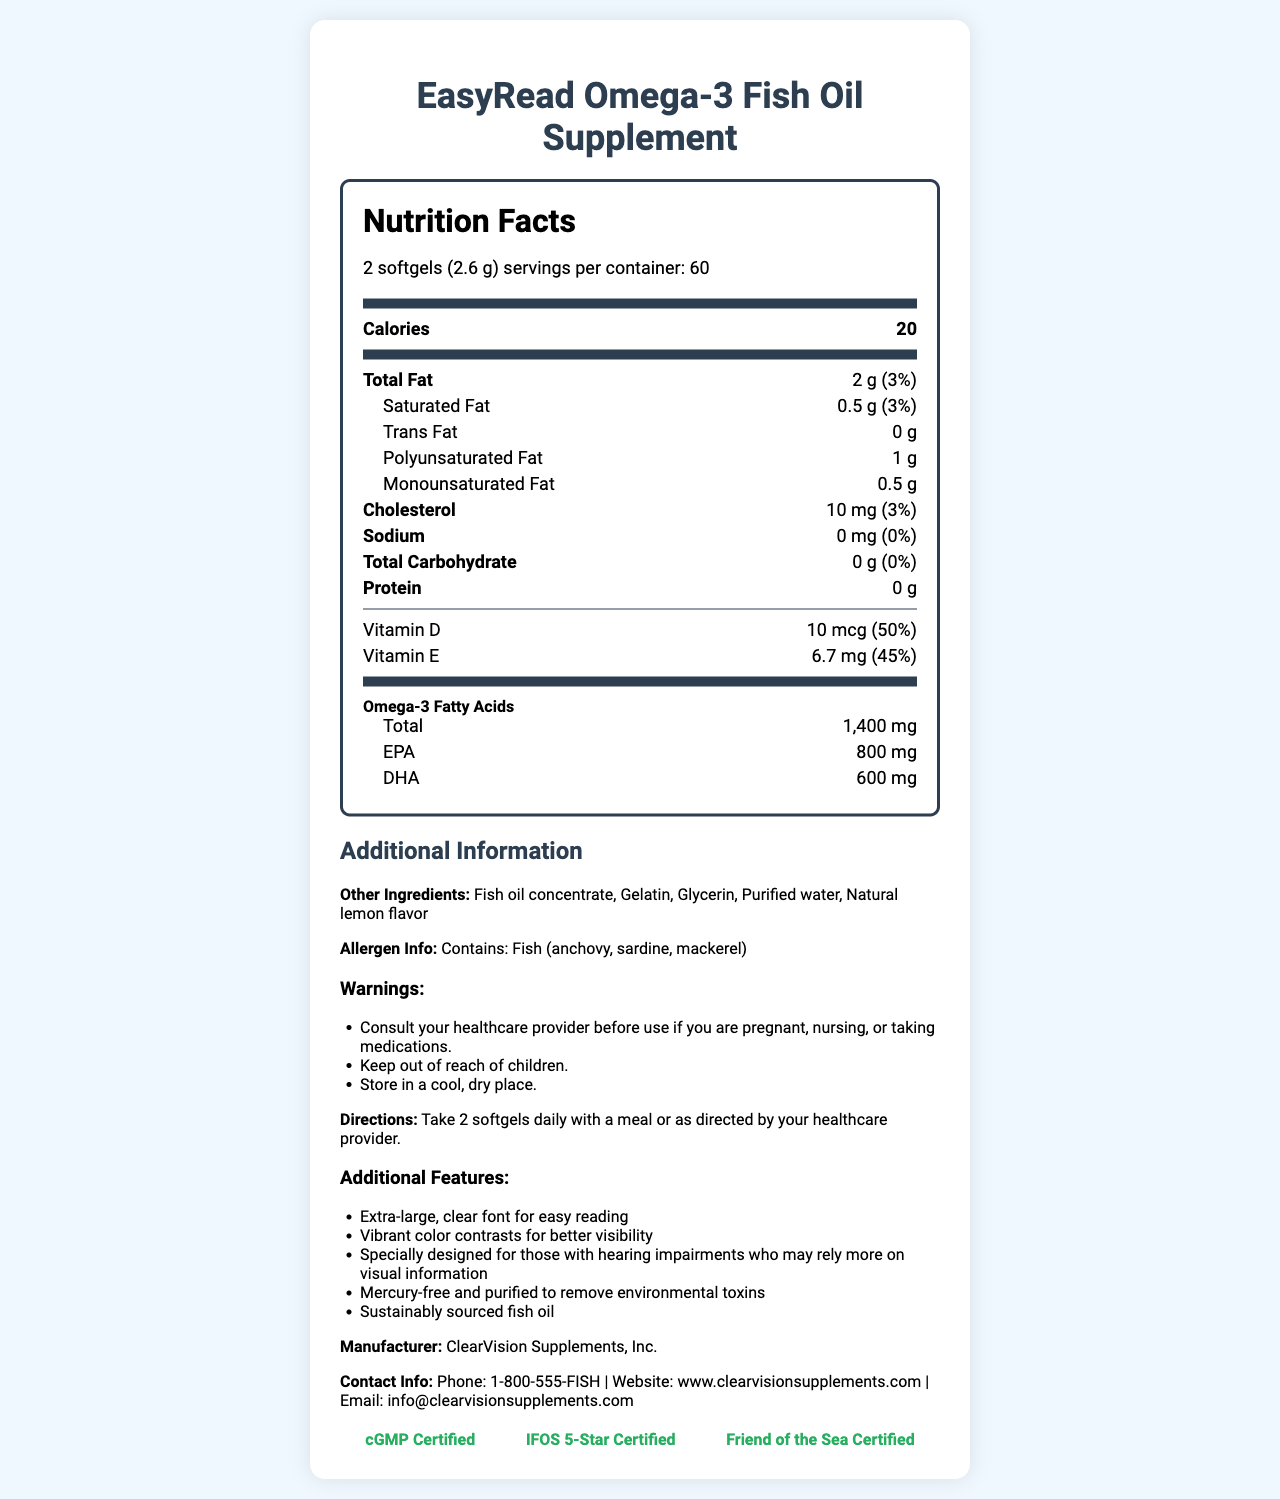how many calories are in one serving of the EasyRead Omega-3 Fish Oil Supplement? The document clearly states that the calories per serving are 20.
Answer: 20 what is the serving size for the EasyRead Omega-3 Fish Oil Supplement? According to the serving information, the serving size is 2 softgels, which is equivalent to 2.6 grams.
Answer: 2 softgels (2.6 g) how much saturated fat is in one serving? The nutrient row for saturated fat shows the amount as 0.5 grams.
Answer: 0.5 g what is the percentage daily value of Vitamin D? The document indicates that the daily value percentage for Vitamin D is 50%.
Answer: 50% which types of fish are included in the allergen information? The allergen information section lists the types of fish as anchovy, sardine, and mackerel.
Answer: Anchovy, sardine, mackerel what is the amount of EPA omega-3 fatty acids in one serving? The omega-3 fatty acids section specifies that there are 800 mg of EPA in one serving.
Answer: 800 mg how is the EasyRead Omega-3 Fish Oil Supplement recommended to be taken? The directions for use state to take 2 softgels daily with a meal or as directed by a healthcare provider.
Answer: Take 2 softgels daily with a meal or as directed by your healthcare provider. what certifications does the EasyRead Omega-3 Fish Oil Supplement have? A. cGMP Certified B. IFOS 5-Star Certified C. Friend of the Sea Certified D. All of the above The certifications section lists cGMP Certified, IFOS 5-Star Certified, and Friend of the Sea Certified, so all of the above is correct.
Answer: D what should you do before using this supplement if you are pregnant or taking medications? A. Nothing special B. Consult your healthcare provider C. Take half the recommended serving The warnings section advises consulting your healthcare provider before use if you are pregnant, nursing, or taking medications.
Answer: B does this supplement contain any sodium? The nutrient row for sodium shows that the amount and daily value percentage are both 0.
Answer: No summarize the main features and information provided about the EasyRead Omega-3 Fish Oil Supplement. The document explains the nutritional facts, serving size, total omega-3 content, additional features for better visibility, allergen information, and contact details for the manufacturer.
Answer: The EasyRead Omega-3 Fish Oil Supplement provides 20 calories per serving, contains 2 grams of total fat, and has significant amounts of omega-3 fatty acids, including EPA and DHA. It also includes vitamins D and E. It is designed with extra-large, clear font for easy reading and includes allergen information and warnings. The supplement is mercury-free, sustainably sourced, and has several certifications. It is manufactured by ClearVision Supplements, Inc., with contact info provided. what is the daily value percentage of total carbohydrate in this supplement? The protein row shows that the daily value percentage for total carbohydrate is 0%.
Answer: 0% how much polyunsaturated fat is in one serving? The row for polyunsaturated fat specifies that one serving contains 1 gram.
Answer: 1 g what is the manufacturer of this supplement? The manufacturer section clearly lists ClearVision Supplements, Inc.
Answer: ClearVision Supplements, Inc. who should store this supplement in a cool, dry place? The warnings and storage instructions state the importance of keeping the product in a cool, dry place, which applies to anyone using it.
Answer: Anyone using the supplement does the document specify if the fish oil is mercury-free? The additional features list mentions that the fish oil is mercury-free.
Answer: Yes who needs to consult a healthcare provider before using this supplement? The warnings section advises individuals who are pregnant, nursing, or taking medications to consult a healthcare provider before use.
Answer: People who are pregnant, nursing, or taking medications how much monounsaturated fat is in one serving? The nutrient row for monounsaturated fat indicates that one serving has 0.5 grams.
Answer: 0.5 g how much cholesterol is in one serving? The nutrient row for cholesterol specifies an amount of 10 mg per serving.
Answer: 10 mg what is the exact expiration date of the EasyRead Omega-3 Fish Oil Supplement? There is no information about the expiration date of the supplement provided in the document.
Answer: Cannot be determined 